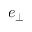<formula> <loc_0><loc_0><loc_500><loc_500>e _ { \perp }</formula> 